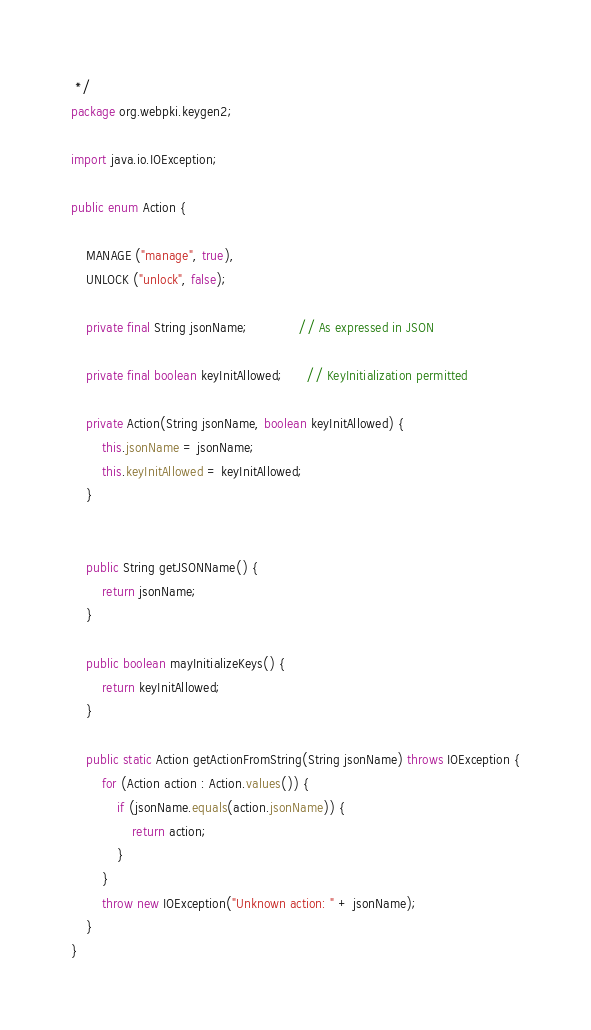Convert code to text. <code><loc_0><loc_0><loc_500><loc_500><_Java_> */
package org.webpki.keygen2;

import java.io.IOException;

public enum Action {

    MANAGE ("manage", true),
    UNLOCK ("unlock", false);

    private final String jsonName;             // As expressed in JSON

    private final boolean keyInitAllowed;      // KeyInitialization permitted

    private Action(String jsonName, boolean keyInitAllowed) {
        this.jsonName = jsonName;
        this.keyInitAllowed = keyInitAllowed;
    }


    public String getJSONName() {
        return jsonName;
    }

    public boolean mayInitializeKeys() {
        return keyInitAllowed;
    }

    public static Action getActionFromString(String jsonName) throws IOException {
        for (Action action : Action.values()) {
            if (jsonName.equals(action.jsonName)) {
                return action;
            }
        }
        throw new IOException("Unknown action: " + jsonName);
    }
}
</code> 